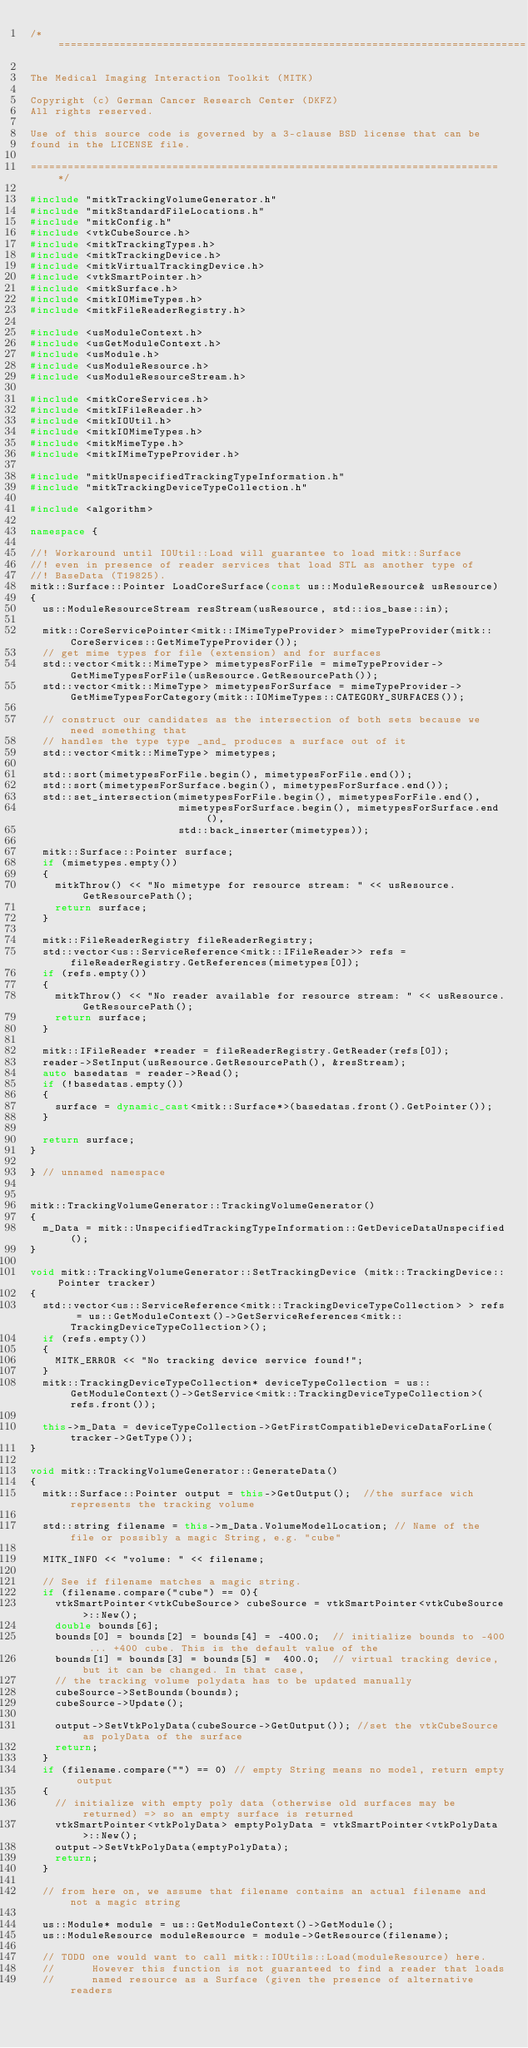Convert code to text. <code><loc_0><loc_0><loc_500><loc_500><_C++_>/*============================================================================

The Medical Imaging Interaction Toolkit (MITK)

Copyright (c) German Cancer Research Center (DKFZ)
All rights reserved.

Use of this source code is governed by a 3-clause BSD license that can be
found in the LICENSE file.

============================================================================*/

#include "mitkTrackingVolumeGenerator.h"
#include "mitkStandardFileLocations.h"
#include "mitkConfig.h"
#include <vtkCubeSource.h>
#include <mitkTrackingTypes.h>
#include <mitkTrackingDevice.h>
#include <mitkVirtualTrackingDevice.h>
#include <vtkSmartPointer.h>
#include <mitkSurface.h>
#include <mitkIOMimeTypes.h>
#include <mitkFileReaderRegistry.h>

#include <usModuleContext.h>
#include <usGetModuleContext.h>
#include <usModule.h>
#include <usModuleResource.h>
#include <usModuleResourceStream.h>

#include <mitkCoreServices.h>
#include <mitkIFileReader.h>
#include <mitkIOUtil.h>
#include <mitkIOMimeTypes.h>
#include <mitkMimeType.h>
#include <mitkIMimeTypeProvider.h>

#include "mitkUnspecifiedTrackingTypeInformation.h"
#include "mitkTrackingDeviceTypeCollection.h"

#include <algorithm>

namespace {

//! Workaround until IOUtil::Load will guarantee to load mitk::Surface
//! even in presence of reader services that load STL as another type of
//! BaseData (T19825).
mitk::Surface::Pointer LoadCoreSurface(const us::ModuleResource& usResource)
{
  us::ModuleResourceStream resStream(usResource, std::ios_base::in);

  mitk::CoreServicePointer<mitk::IMimeTypeProvider> mimeTypeProvider(mitk::CoreServices::GetMimeTypeProvider());
  // get mime types for file (extension) and for surfaces
  std::vector<mitk::MimeType> mimetypesForFile = mimeTypeProvider->GetMimeTypesForFile(usResource.GetResourcePath());
  std::vector<mitk::MimeType> mimetypesForSurface = mimeTypeProvider->GetMimeTypesForCategory(mitk::IOMimeTypes::CATEGORY_SURFACES());

  // construct our candidates as the intersection of both sets because we need something that
  // handles the type type _and_ produces a surface out of it
  std::vector<mitk::MimeType> mimetypes;

  std::sort(mimetypesForFile.begin(), mimetypesForFile.end());
  std::sort(mimetypesForSurface.begin(), mimetypesForSurface.end());
  std::set_intersection(mimetypesForFile.begin(), mimetypesForFile.end(),
                        mimetypesForSurface.begin(), mimetypesForSurface.end(),
                        std::back_inserter(mimetypes));

  mitk::Surface::Pointer surface;
  if (mimetypes.empty())
  {
    mitkThrow() << "No mimetype for resource stream: " << usResource.GetResourcePath();
    return surface;
  }

  mitk::FileReaderRegistry fileReaderRegistry;
  std::vector<us::ServiceReference<mitk::IFileReader>> refs = fileReaderRegistry.GetReferences(mimetypes[0]);
  if (refs.empty())
  {
    mitkThrow() << "No reader available for resource stream: " << usResource.GetResourcePath();
    return surface;
  }

  mitk::IFileReader *reader = fileReaderRegistry.GetReader(refs[0]);
  reader->SetInput(usResource.GetResourcePath(), &resStream);
  auto basedatas = reader->Read();
  if (!basedatas.empty())
  {
    surface = dynamic_cast<mitk::Surface*>(basedatas.front().GetPointer());
  }

  return surface;
}

} // unnamed namespace


mitk::TrackingVolumeGenerator::TrackingVolumeGenerator()
{
  m_Data = mitk::UnspecifiedTrackingTypeInformation::GetDeviceDataUnspecified();
}

void mitk::TrackingVolumeGenerator::SetTrackingDevice (mitk::TrackingDevice::Pointer tracker)
{
  std::vector<us::ServiceReference<mitk::TrackingDeviceTypeCollection> > refs = us::GetModuleContext()->GetServiceReferences<mitk::TrackingDeviceTypeCollection>();
  if (refs.empty())
  {
    MITK_ERROR << "No tracking device service found!";
  }
  mitk::TrackingDeviceTypeCollection* deviceTypeCollection = us::GetModuleContext()->GetService<mitk::TrackingDeviceTypeCollection>(refs.front());

  this->m_Data = deviceTypeCollection->GetFirstCompatibleDeviceDataForLine(tracker->GetType());
}

void mitk::TrackingVolumeGenerator::GenerateData()
{
  mitk::Surface::Pointer output = this->GetOutput();  //the surface wich represents the tracking volume

  std::string filename = this->m_Data.VolumeModelLocation; // Name of the file or possibly a magic String, e.g. "cube"

  MITK_INFO << "volume: " << filename;

  // See if filename matches a magic string.
  if (filename.compare("cube") == 0){
    vtkSmartPointer<vtkCubeSource> cubeSource = vtkSmartPointer<vtkCubeSource>::New();
    double bounds[6];
    bounds[0] = bounds[2] = bounds[4] = -400.0;  // initialize bounds to -400 ... +400 cube. This is the default value of the
    bounds[1] = bounds[3] = bounds[5] =  400.0;  // virtual tracking device, but it can be changed. In that case,
    // the tracking volume polydata has to be updated manually
    cubeSource->SetBounds(bounds);
    cubeSource->Update();

    output->SetVtkPolyData(cubeSource->GetOutput()); //set the vtkCubeSource as polyData of the surface
    return;
  }
  if (filename.compare("") == 0) // empty String means no model, return empty output
  {
    // initialize with empty poly data (otherwise old surfaces may be returned) => so an empty surface is returned
    vtkSmartPointer<vtkPolyData> emptyPolyData = vtkSmartPointer<vtkPolyData>::New();
    output->SetVtkPolyData(emptyPolyData);
    return;
  }

  // from here on, we assume that filename contains an actual filename and not a magic string

  us::Module* module = us::GetModuleContext()->GetModule();
  us::ModuleResource moduleResource = module->GetResource(filename);

  // TODO one would want to call mitk::IOUtils::Load(moduleResource) here.
  //      However this function is not guaranteed to find a reader that loads
  //      named resource as a Surface (given the presence of alternative readers</code> 